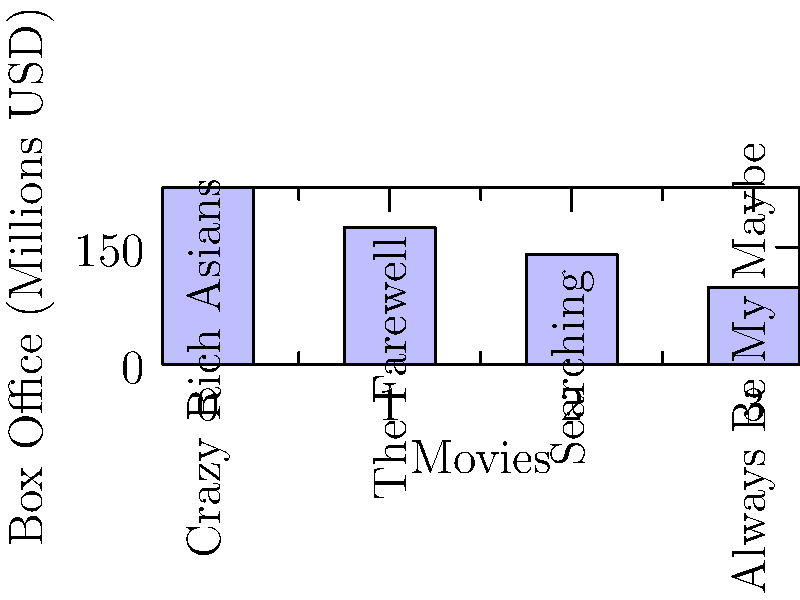Based on the bar graph showing the box office performance of films with Asian-American leads, which movie grossed approximately $40 million more than "The Farewell"? To answer this question, we need to follow these steps:

1. Identify the box office earnings for "The Farewell" from the graph:
   "The Farewell" earned approximately $174.51 million.

2. Add $40 million to this figure:
   $174.51 million + $40 million = $214.51 million

3. Look for a movie with box office earnings close to $214.51 million:
   "Crazy Rich Asians" shows earnings of about $225.76 million, which is the closest to our calculated value.

4. Verify the difference:
   $225.76 million - $174.51 million = $51.25 million

While this is not exactly $40 million, it is the closest match among the given movies and fits the "approximately" criterion in the question.
Answer: Crazy Rich Asians 